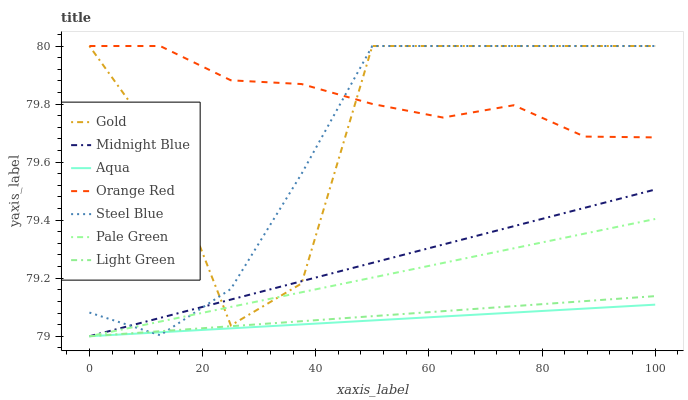Does Aqua have the minimum area under the curve?
Answer yes or no. Yes. Does Orange Red have the maximum area under the curve?
Answer yes or no. Yes. Does Gold have the minimum area under the curve?
Answer yes or no. No. Does Gold have the maximum area under the curve?
Answer yes or no. No. Is Aqua the smoothest?
Answer yes or no. Yes. Is Gold the roughest?
Answer yes or no. Yes. Is Gold the smoothest?
Answer yes or no. No. Is Aqua the roughest?
Answer yes or no. No. Does Midnight Blue have the lowest value?
Answer yes or no. Yes. Does Gold have the lowest value?
Answer yes or no. No. Does Orange Red have the highest value?
Answer yes or no. Yes. Does Aqua have the highest value?
Answer yes or no. No. Is Pale Green less than Orange Red?
Answer yes or no. Yes. Is Gold greater than Aqua?
Answer yes or no. Yes. Does Gold intersect Pale Green?
Answer yes or no. Yes. Is Gold less than Pale Green?
Answer yes or no. No. Is Gold greater than Pale Green?
Answer yes or no. No. Does Pale Green intersect Orange Red?
Answer yes or no. No. 